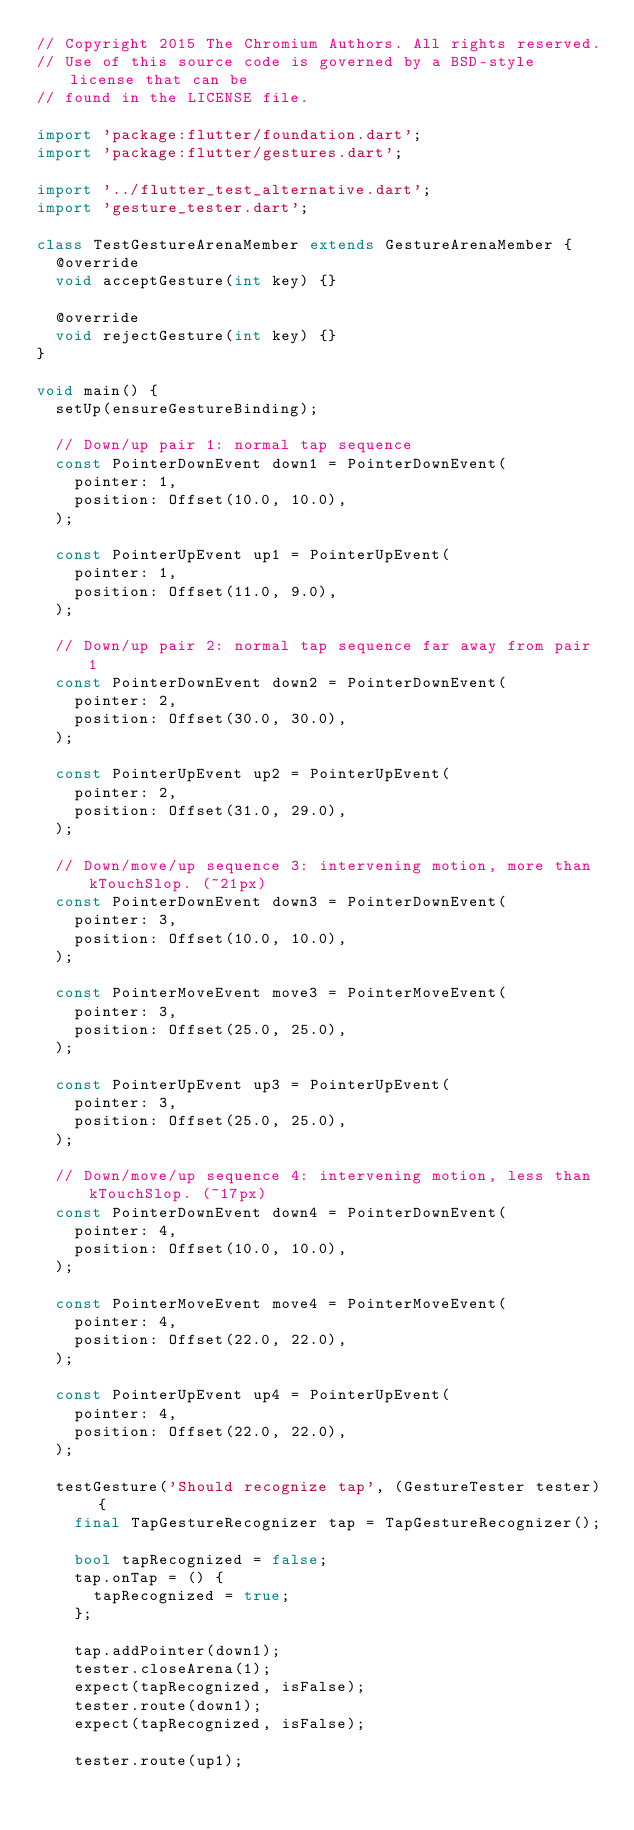<code> <loc_0><loc_0><loc_500><loc_500><_Dart_>// Copyright 2015 The Chromium Authors. All rights reserved.
// Use of this source code is governed by a BSD-style license that can be
// found in the LICENSE file.

import 'package:flutter/foundation.dart';
import 'package:flutter/gestures.dart';

import '../flutter_test_alternative.dart';
import 'gesture_tester.dart';

class TestGestureArenaMember extends GestureArenaMember {
  @override
  void acceptGesture(int key) {}

  @override
  void rejectGesture(int key) {}
}

void main() {
  setUp(ensureGestureBinding);

  // Down/up pair 1: normal tap sequence
  const PointerDownEvent down1 = PointerDownEvent(
    pointer: 1,
    position: Offset(10.0, 10.0),
  );

  const PointerUpEvent up1 = PointerUpEvent(
    pointer: 1,
    position: Offset(11.0, 9.0),
  );

  // Down/up pair 2: normal tap sequence far away from pair 1
  const PointerDownEvent down2 = PointerDownEvent(
    pointer: 2,
    position: Offset(30.0, 30.0),
  );

  const PointerUpEvent up2 = PointerUpEvent(
    pointer: 2,
    position: Offset(31.0, 29.0),
  );

  // Down/move/up sequence 3: intervening motion, more than kTouchSlop. (~21px)
  const PointerDownEvent down3 = PointerDownEvent(
    pointer: 3,
    position: Offset(10.0, 10.0),
  );

  const PointerMoveEvent move3 = PointerMoveEvent(
    pointer: 3,
    position: Offset(25.0, 25.0),
  );

  const PointerUpEvent up3 = PointerUpEvent(
    pointer: 3,
    position: Offset(25.0, 25.0),
  );

  // Down/move/up sequence 4: intervening motion, less than kTouchSlop. (~17px)
  const PointerDownEvent down4 = PointerDownEvent(
    pointer: 4,
    position: Offset(10.0, 10.0),
  );

  const PointerMoveEvent move4 = PointerMoveEvent(
    pointer: 4,
    position: Offset(22.0, 22.0),
  );

  const PointerUpEvent up4 = PointerUpEvent(
    pointer: 4,
    position: Offset(22.0, 22.0),
  );

  testGesture('Should recognize tap', (GestureTester tester) {
    final TapGestureRecognizer tap = TapGestureRecognizer();

    bool tapRecognized = false;
    tap.onTap = () {
      tapRecognized = true;
    };

    tap.addPointer(down1);
    tester.closeArena(1);
    expect(tapRecognized, isFalse);
    tester.route(down1);
    expect(tapRecognized, isFalse);

    tester.route(up1);</code> 